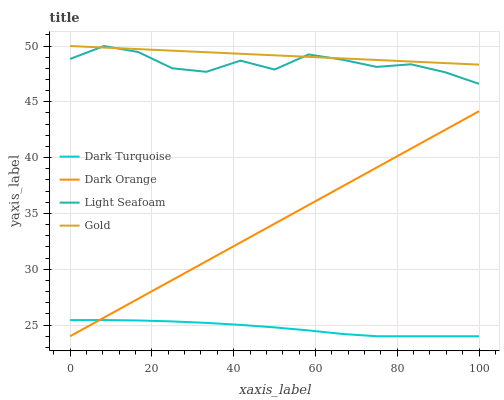Does Dark Turquoise have the minimum area under the curve?
Answer yes or no. Yes. Does Gold have the maximum area under the curve?
Answer yes or no. Yes. Does Light Seafoam have the minimum area under the curve?
Answer yes or no. No. Does Light Seafoam have the maximum area under the curve?
Answer yes or no. No. Is Dark Orange the smoothest?
Answer yes or no. Yes. Is Light Seafoam the roughest?
Answer yes or no. Yes. Is Gold the smoothest?
Answer yes or no. No. Is Gold the roughest?
Answer yes or no. No. Does Dark Turquoise have the lowest value?
Answer yes or no. Yes. Does Light Seafoam have the lowest value?
Answer yes or no. No. Does Gold have the highest value?
Answer yes or no. Yes. Does Dark Orange have the highest value?
Answer yes or no. No. Is Dark Orange less than Gold?
Answer yes or no. Yes. Is Gold greater than Dark Orange?
Answer yes or no. Yes. Does Dark Orange intersect Dark Turquoise?
Answer yes or no. Yes. Is Dark Orange less than Dark Turquoise?
Answer yes or no. No. Is Dark Orange greater than Dark Turquoise?
Answer yes or no. No. Does Dark Orange intersect Gold?
Answer yes or no. No. 